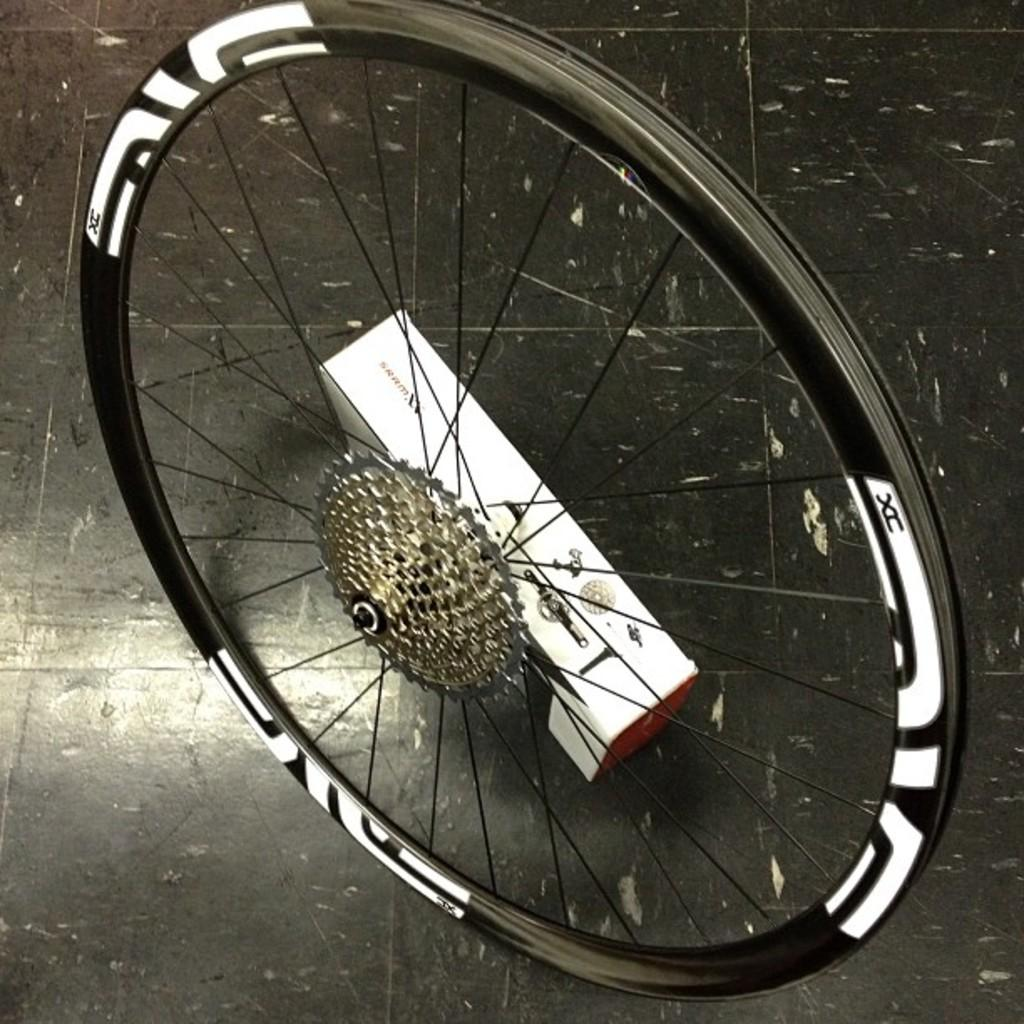What type of vehicles are in the image? There are bicycles in the image. Where are the bicycles located? The bicycles are on the floor. What is the color and shape of the box in the image? There is a white color box in the image. Where is the white color box placed in relation to the bicycles? The white color box is beside the bicycles. What type of wax is used to create the thought-provoking salt sculpture in the image? There is no wax, thought, or salt sculpture present in the image; it features bicycles and a white color box. 